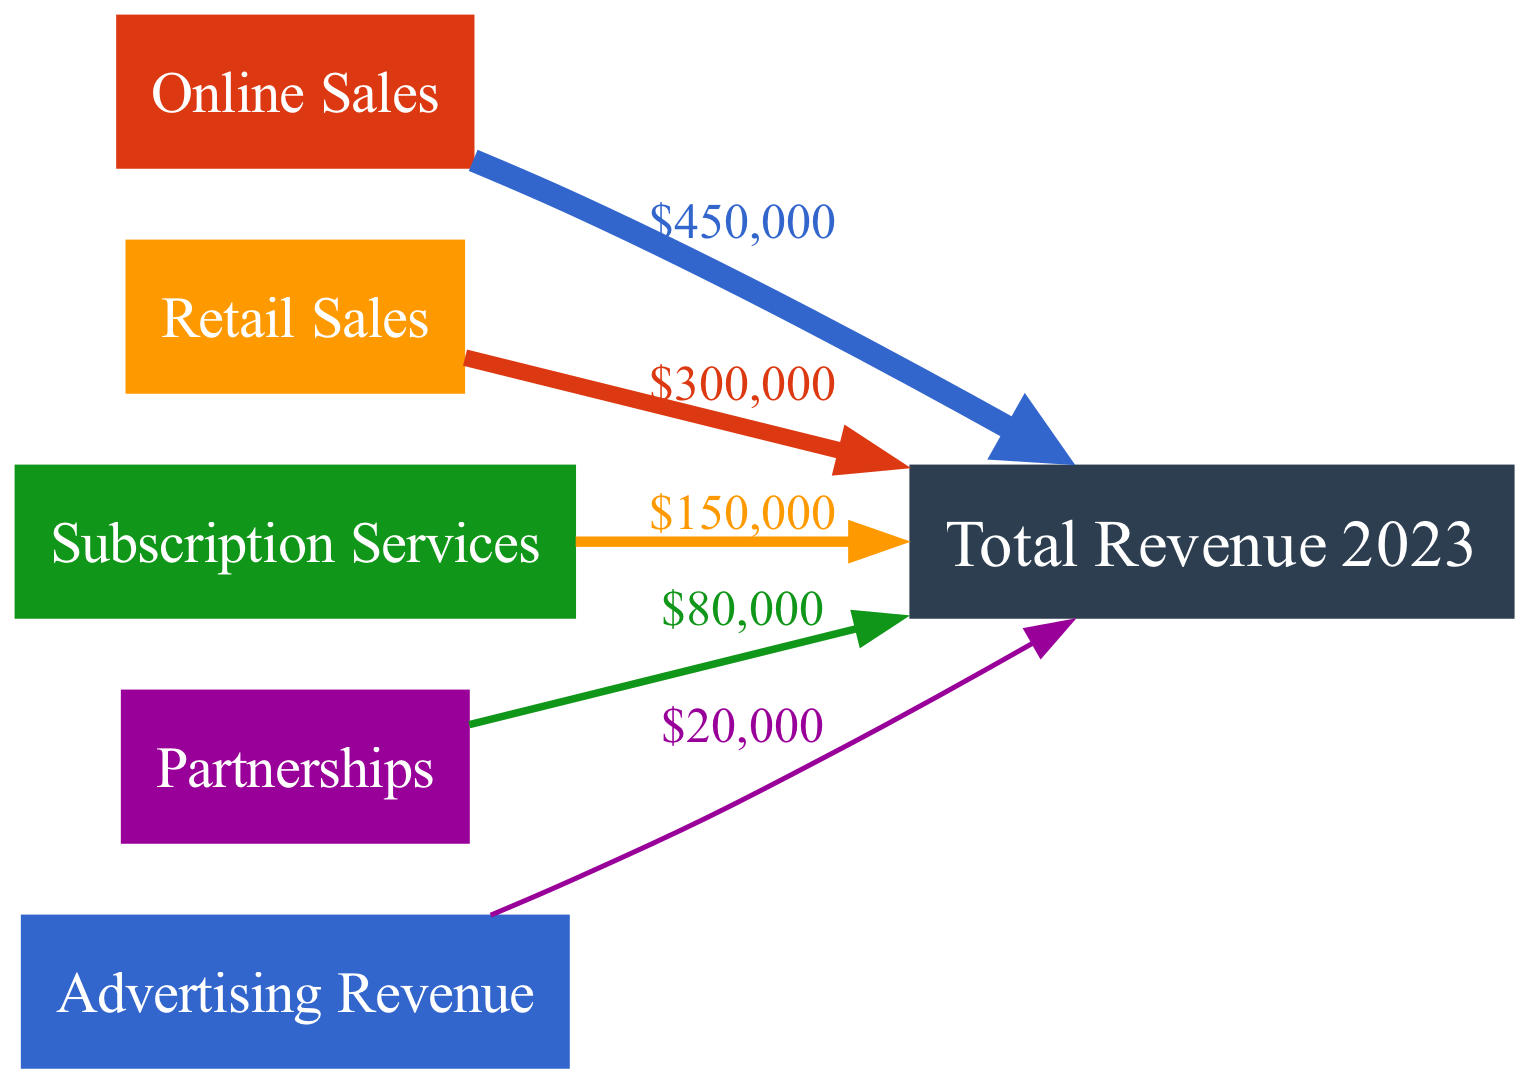What is the total revenue for 2023? The diagram indicates the total revenue node labeled "Total Revenue 2023" which aggregates all incoming revenue streams. By identifying this node and looking for the overall contribution mentioned, we find that the total revenue is $1,000,000.
Answer: $1,000,000 Which revenue stream has the highest contribution? Looking at the edges connecting the nodes to the "Total Revenue" node, we observe the values of each contributing stream. The "Online Sales" stream has the highest value, which is $450,000.
Answer: $450,000 What percentage of total revenue comes from Retail Sales? To determine this, we look at the Retail Sales stream, which contributes $300,000. We then compute the percentage by dividing $300,000 by the total revenue of $1,000,000 and multiplying by 100, resulting in 30%.
Answer: 30% How many distinct revenue streams are there? The diagram displays five distinct nodes contributing to total revenue: Online Sales, Retail Sales, Subscription Services, Partnerships, and Advertising. Counting these nodes gives us five distinct revenue streams.
Answer: 5 What is the combined contribution of Partnerships and Advertising? From the diagram, we see that "Partnerships" contributes $80,000 and "Advertising" contributes $20,000. By summing these two values, we get $100,000 as the combined contribution.
Answer: $100,000 Which revenue stream contributes the least? By examining the values presented in the diagram, the "Advertising Revenue" stream shows a contribution of $20,000, which is the lowest among all revenue streams.
Answer: $20,000 What is the total contribution from Subscription Services? The edge leading from "Subscription Services" to "Total Revenue" shows its contribution explicitly labeled as $150,000, indicating this is the total contribution from that revenue stream.
Answer: $150,000 What fraction of the total revenue is represented by Online Sales in comparison to total revenue? The "Online Sales" contribution is noted as $450,000. To find its fraction of the total revenue of $1,000,000, we take $450,000 and divide it by $1,000,000, resulting in a fraction of 0.45 or 45%.
Answer: 45% Which two revenue streams combined contribute more than half of the total revenue? By assessing the contributions, "Online Sales" ($450,000) combined with "Retail Sales" ($300,000) totals to $750,000 together, which exceeds half of the total revenue, which is $500,000.
Answer: Online Sales and Retail Sales 